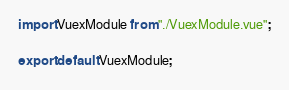<code> <loc_0><loc_0><loc_500><loc_500><_TypeScript_>import VuexModule from "./VuexModule.vue";

export default VuexModule;
</code> 